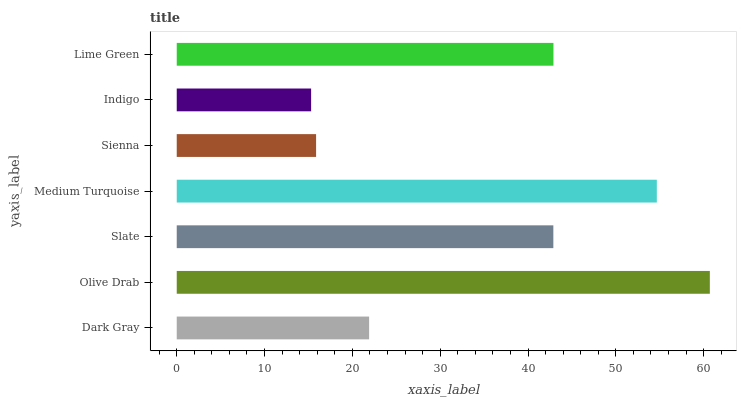Is Indigo the minimum?
Answer yes or no. Yes. Is Olive Drab the maximum?
Answer yes or no. Yes. Is Slate the minimum?
Answer yes or no. No. Is Slate the maximum?
Answer yes or no. No. Is Olive Drab greater than Slate?
Answer yes or no. Yes. Is Slate less than Olive Drab?
Answer yes or no. Yes. Is Slate greater than Olive Drab?
Answer yes or no. No. Is Olive Drab less than Slate?
Answer yes or no. No. Is Slate the high median?
Answer yes or no. Yes. Is Slate the low median?
Answer yes or no. Yes. Is Dark Gray the high median?
Answer yes or no. No. Is Sienna the low median?
Answer yes or no. No. 